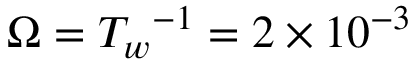Convert formula to latex. <formula><loc_0><loc_0><loc_500><loc_500>\Omega = { T _ { w } } ^ { - 1 } = 2 \times 1 0 ^ { - 3 }</formula> 